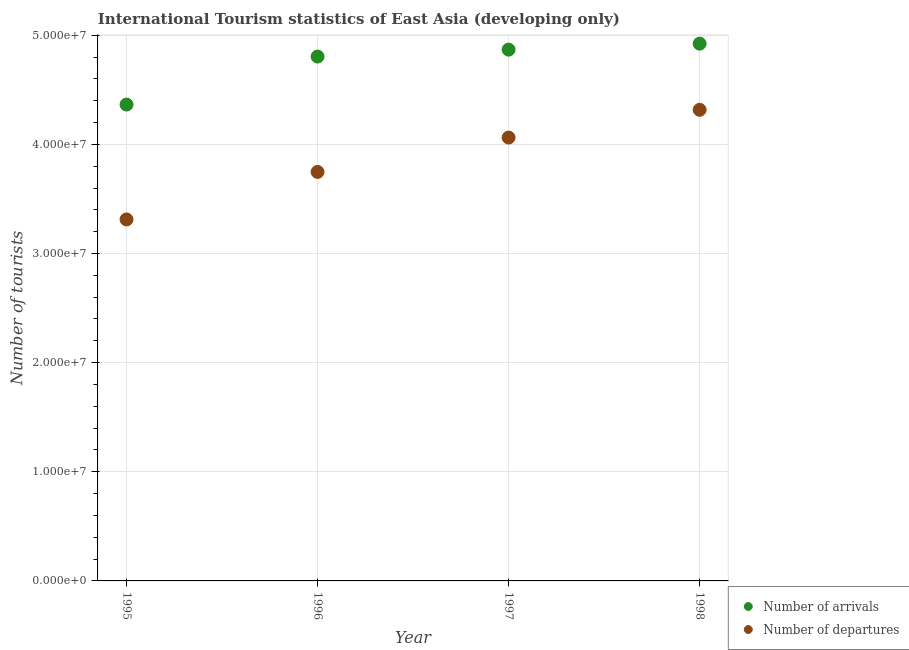What is the number of tourist departures in 1995?
Give a very brief answer. 3.31e+07. Across all years, what is the maximum number of tourist departures?
Your response must be concise. 4.32e+07. Across all years, what is the minimum number of tourist arrivals?
Offer a very short reply. 4.36e+07. What is the total number of tourist departures in the graph?
Make the answer very short. 1.54e+08. What is the difference between the number of tourist arrivals in 1995 and that in 1996?
Provide a short and direct response. -4.40e+06. What is the difference between the number of tourist departures in 1998 and the number of tourist arrivals in 1995?
Your response must be concise. -4.81e+05. What is the average number of tourist arrivals per year?
Your answer should be compact. 4.74e+07. In the year 1997, what is the difference between the number of tourist departures and number of tourist arrivals?
Provide a short and direct response. -8.06e+06. What is the ratio of the number of tourist departures in 1995 to that in 1998?
Provide a short and direct response. 0.77. What is the difference between the highest and the second highest number of tourist arrivals?
Your answer should be compact. 5.46e+05. What is the difference between the highest and the lowest number of tourist arrivals?
Offer a terse response. 5.58e+06. Is the sum of the number of tourist departures in 1995 and 1996 greater than the maximum number of tourist arrivals across all years?
Keep it short and to the point. Yes. Is the number of tourist arrivals strictly greater than the number of tourist departures over the years?
Your answer should be very brief. Yes. Is the number of tourist arrivals strictly less than the number of tourist departures over the years?
Your response must be concise. No. How many dotlines are there?
Provide a short and direct response. 2. How many years are there in the graph?
Your answer should be very brief. 4. Where does the legend appear in the graph?
Offer a terse response. Bottom right. What is the title of the graph?
Make the answer very short. International Tourism statistics of East Asia (developing only). What is the label or title of the Y-axis?
Your response must be concise. Number of tourists. What is the Number of tourists of Number of arrivals in 1995?
Ensure brevity in your answer.  4.36e+07. What is the Number of tourists of Number of departures in 1995?
Keep it short and to the point. 3.31e+07. What is the Number of tourists in Number of arrivals in 1996?
Give a very brief answer. 4.80e+07. What is the Number of tourists of Number of departures in 1996?
Provide a short and direct response. 3.75e+07. What is the Number of tourists of Number of arrivals in 1997?
Make the answer very short. 4.87e+07. What is the Number of tourists in Number of departures in 1997?
Provide a succinct answer. 4.06e+07. What is the Number of tourists of Number of arrivals in 1998?
Offer a very short reply. 4.92e+07. What is the Number of tourists of Number of departures in 1998?
Keep it short and to the point. 4.32e+07. Across all years, what is the maximum Number of tourists in Number of arrivals?
Offer a very short reply. 4.92e+07. Across all years, what is the maximum Number of tourists in Number of departures?
Ensure brevity in your answer.  4.32e+07. Across all years, what is the minimum Number of tourists in Number of arrivals?
Give a very brief answer. 4.36e+07. Across all years, what is the minimum Number of tourists of Number of departures?
Keep it short and to the point. 3.31e+07. What is the total Number of tourists of Number of arrivals in the graph?
Give a very brief answer. 1.90e+08. What is the total Number of tourists of Number of departures in the graph?
Make the answer very short. 1.54e+08. What is the difference between the Number of tourists in Number of arrivals in 1995 and that in 1996?
Your answer should be very brief. -4.40e+06. What is the difference between the Number of tourists of Number of departures in 1995 and that in 1996?
Offer a terse response. -4.35e+06. What is the difference between the Number of tourists in Number of arrivals in 1995 and that in 1997?
Provide a short and direct response. -5.03e+06. What is the difference between the Number of tourists in Number of departures in 1995 and that in 1997?
Your answer should be very brief. -7.50e+06. What is the difference between the Number of tourists of Number of arrivals in 1995 and that in 1998?
Keep it short and to the point. -5.58e+06. What is the difference between the Number of tourists of Number of departures in 1995 and that in 1998?
Your answer should be very brief. -1.00e+07. What is the difference between the Number of tourists in Number of arrivals in 1996 and that in 1997?
Ensure brevity in your answer.  -6.36e+05. What is the difference between the Number of tourists of Number of departures in 1996 and that in 1997?
Ensure brevity in your answer.  -3.15e+06. What is the difference between the Number of tourists in Number of arrivals in 1996 and that in 1998?
Offer a very short reply. -1.18e+06. What is the difference between the Number of tourists in Number of departures in 1996 and that in 1998?
Provide a succinct answer. -5.69e+06. What is the difference between the Number of tourists of Number of arrivals in 1997 and that in 1998?
Your response must be concise. -5.46e+05. What is the difference between the Number of tourists in Number of departures in 1997 and that in 1998?
Provide a succinct answer. -2.54e+06. What is the difference between the Number of tourists in Number of arrivals in 1995 and the Number of tourists in Number of departures in 1996?
Keep it short and to the point. 6.17e+06. What is the difference between the Number of tourists in Number of arrivals in 1995 and the Number of tourists in Number of departures in 1997?
Provide a succinct answer. 3.02e+06. What is the difference between the Number of tourists in Number of arrivals in 1995 and the Number of tourists in Number of departures in 1998?
Give a very brief answer. 4.81e+05. What is the difference between the Number of tourists of Number of arrivals in 1996 and the Number of tourists of Number of departures in 1997?
Your response must be concise. 7.42e+06. What is the difference between the Number of tourists in Number of arrivals in 1996 and the Number of tourists in Number of departures in 1998?
Ensure brevity in your answer.  4.88e+06. What is the difference between the Number of tourists of Number of arrivals in 1997 and the Number of tourists of Number of departures in 1998?
Your response must be concise. 5.51e+06. What is the average Number of tourists in Number of arrivals per year?
Offer a very short reply. 4.74e+07. What is the average Number of tourists of Number of departures per year?
Provide a short and direct response. 3.86e+07. In the year 1995, what is the difference between the Number of tourists in Number of arrivals and Number of tourists in Number of departures?
Your answer should be very brief. 1.05e+07. In the year 1996, what is the difference between the Number of tourists of Number of arrivals and Number of tourists of Number of departures?
Offer a very short reply. 1.06e+07. In the year 1997, what is the difference between the Number of tourists of Number of arrivals and Number of tourists of Number of departures?
Give a very brief answer. 8.06e+06. In the year 1998, what is the difference between the Number of tourists of Number of arrivals and Number of tourists of Number of departures?
Give a very brief answer. 6.06e+06. What is the ratio of the Number of tourists of Number of arrivals in 1995 to that in 1996?
Your answer should be very brief. 0.91. What is the ratio of the Number of tourists of Number of departures in 1995 to that in 1996?
Ensure brevity in your answer.  0.88. What is the ratio of the Number of tourists of Number of arrivals in 1995 to that in 1997?
Offer a very short reply. 0.9. What is the ratio of the Number of tourists of Number of departures in 1995 to that in 1997?
Offer a terse response. 0.82. What is the ratio of the Number of tourists of Number of arrivals in 1995 to that in 1998?
Ensure brevity in your answer.  0.89. What is the ratio of the Number of tourists in Number of departures in 1995 to that in 1998?
Provide a succinct answer. 0.77. What is the ratio of the Number of tourists in Number of arrivals in 1996 to that in 1997?
Offer a very short reply. 0.99. What is the ratio of the Number of tourists of Number of departures in 1996 to that in 1997?
Your answer should be compact. 0.92. What is the ratio of the Number of tourists of Number of arrivals in 1996 to that in 1998?
Your answer should be compact. 0.98. What is the ratio of the Number of tourists in Number of departures in 1996 to that in 1998?
Provide a short and direct response. 0.87. What is the ratio of the Number of tourists in Number of arrivals in 1997 to that in 1998?
Offer a terse response. 0.99. What is the ratio of the Number of tourists of Number of departures in 1997 to that in 1998?
Keep it short and to the point. 0.94. What is the difference between the highest and the second highest Number of tourists of Number of arrivals?
Make the answer very short. 5.46e+05. What is the difference between the highest and the second highest Number of tourists in Number of departures?
Offer a very short reply. 2.54e+06. What is the difference between the highest and the lowest Number of tourists in Number of arrivals?
Give a very brief answer. 5.58e+06. What is the difference between the highest and the lowest Number of tourists of Number of departures?
Ensure brevity in your answer.  1.00e+07. 